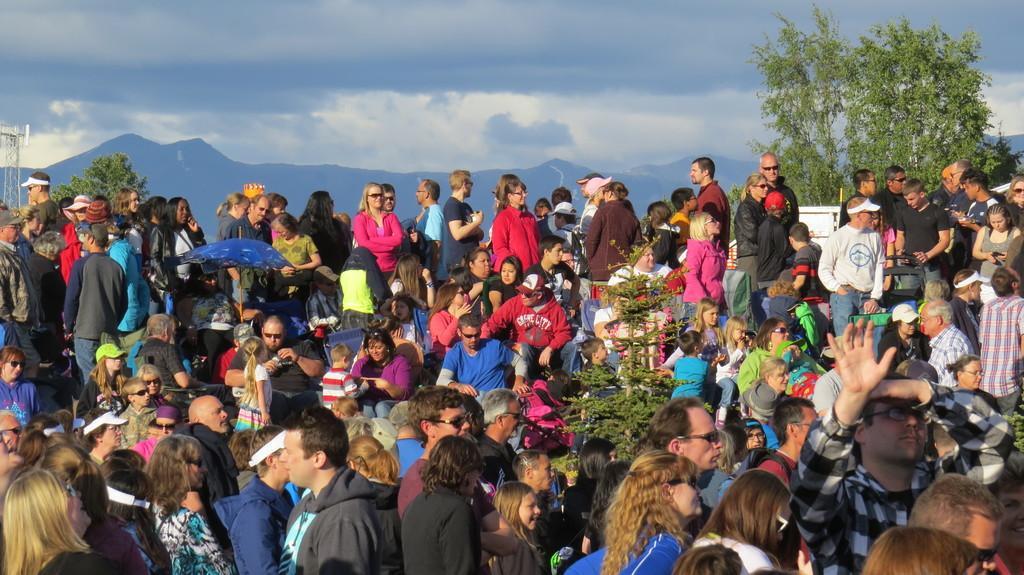In one or two sentences, can you explain what this image depicts? In this image there is a huge crowd of people. There is a plant in the middle. There are trees. There are mountains in the background. There are clouds in the sky. 